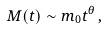<formula> <loc_0><loc_0><loc_500><loc_500>M ( t ) \sim m _ { 0 } t ^ { \theta } \, ,</formula> 